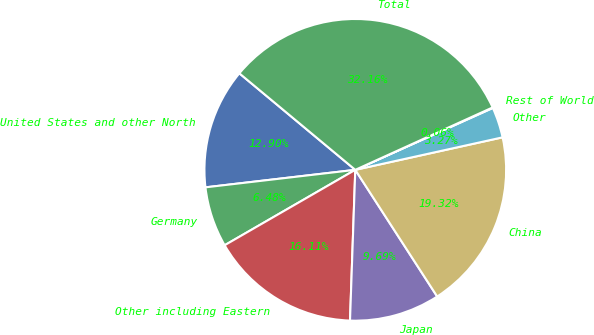Convert chart to OTSL. <chart><loc_0><loc_0><loc_500><loc_500><pie_chart><fcel>United States and other North<fcel>Germany<fcel>Other including Eastern<fcel>Japan<fcel>China<fcel>Other<fcel>Rest of World<fcel>Total<nl><fcel>12.9%<fcel>6.48%<fcel>16.11%<fcel>9.69%<fcel>19.32%<fcel>3.27%<fcel>0.06%<fcel>32.16%<nl></chart> 